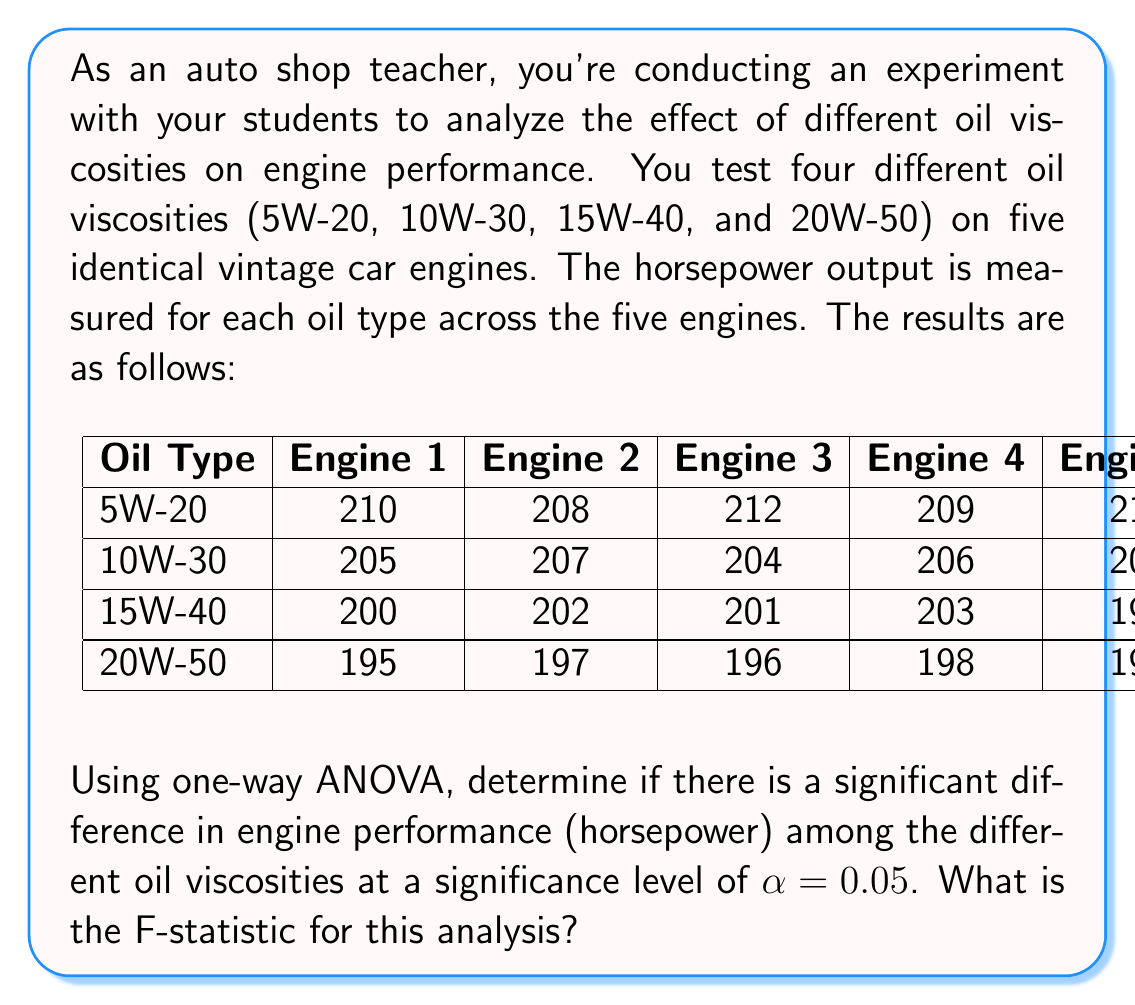Can you solve this math problem? Let's solve this step-by-step using one-way ANOVA:

1) First, calculate the sum of squares:

   a) Total sum of squares (SST):
      $$SST = \sum_{i=1}^{4}\sum_{j=1}^{5} (X_{ij} - \bar{X})^2$$
      where $\bar{X}$ is the grand mean.

   b) Between-group sum of squares (SSB):
      $$SSB = \sum_{i=1}^{4} n_i(\bar{X_i} - \bar{X})^2$$
      where $n_i$ is the number of observations in each group (5 in this case),
      and $\bar{X_i}$ is the mean of each group.

   c) Within-group sum of squares (SSW):
      $$SSW = SST - SSB$$

2) Calculate the degrees of freedom:
   - Total df: $N - 1 = 20 - 1 = 19$
   - Between-group df: $k - 1 = 4 - 1 = 3$
   - Within-group df: $N - k = 20 - 4 = 16$

3) Calculate the mean squares:
   $$MSB = \frac{SSB}{3}$$
   $$MSW = \frac{SSW}{16}$$

4) Calculate the F-statistic:
   $$F = \frac{MSB}{MSW}$$

Performing these calculations:

$\bar{X} = 203$

SST = 882
SSB = 850
SSW = 32

MSB = 283.33
MSW = 2

F = 141.67

5) The critical F-value for $\alpha = 0.05$, with 3 and 16 degrees of freedom, is approximately 3.24.

Since our calculated F-statistic (141.67) is greater than the critical F-value (3.24), we reject the null hypothesis. This means there is a significant difference in engine performance among the different oil viscosities.
Answer: F = 141.67 